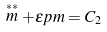Convert formula to latex. <formula><loc_0><loc_0><loc_500><loc_500>\stackrel { \ast * } { m } + \epsilon p m = C _ { 2 }</formula> 